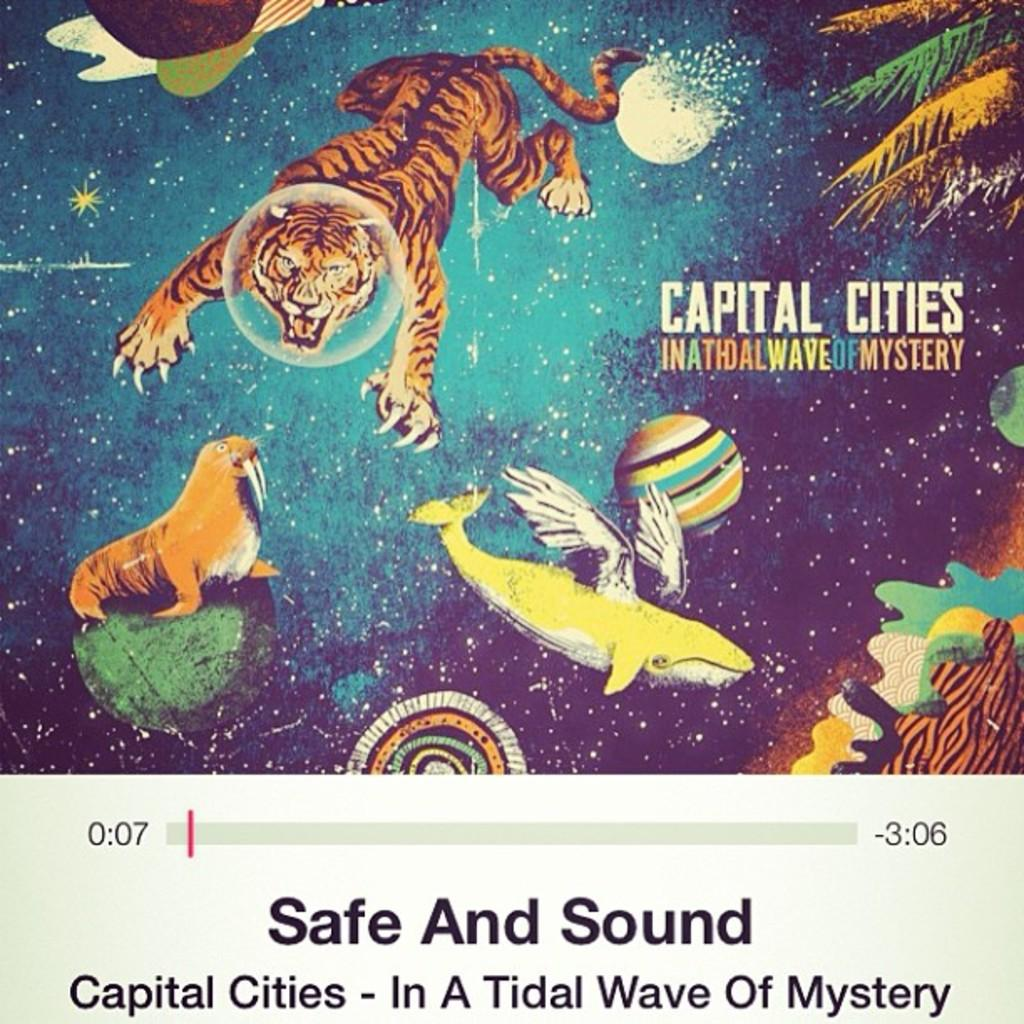What type of publication is shown in the image? The image is a magazine. What can be found within the pages of the magazine? There is text and pictures in the magazine. What type of pictures are included in the magazine? There are pictures of animals and trees in the magazine. What type of tank is featured in the magazine? There is no tank present in the magazine; it contains pictures of animals and trees. How does the magazine show respect for the environment? The magazine does not explicitly show respect for the environment, but it may contain articles or images related to environmental topics. 